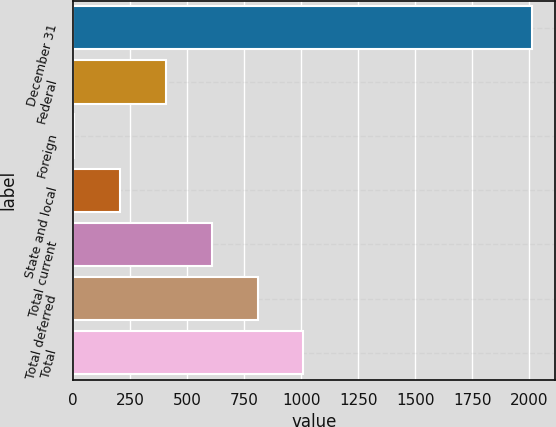<chart> <loc_0><loc_0><loc_500><loc_500><bar_chart><fcel>December 31<fcel>Federal<fcel>Foreign<fcel>State and local<fcel>Total current<fcel>Total deferred<fcel>Total<nl><fcel>2012<fcel>407.2<fcel>6<fcel>206.6<fcel>607.8<fcel>808.4<fcel>1009<nl></chart> 